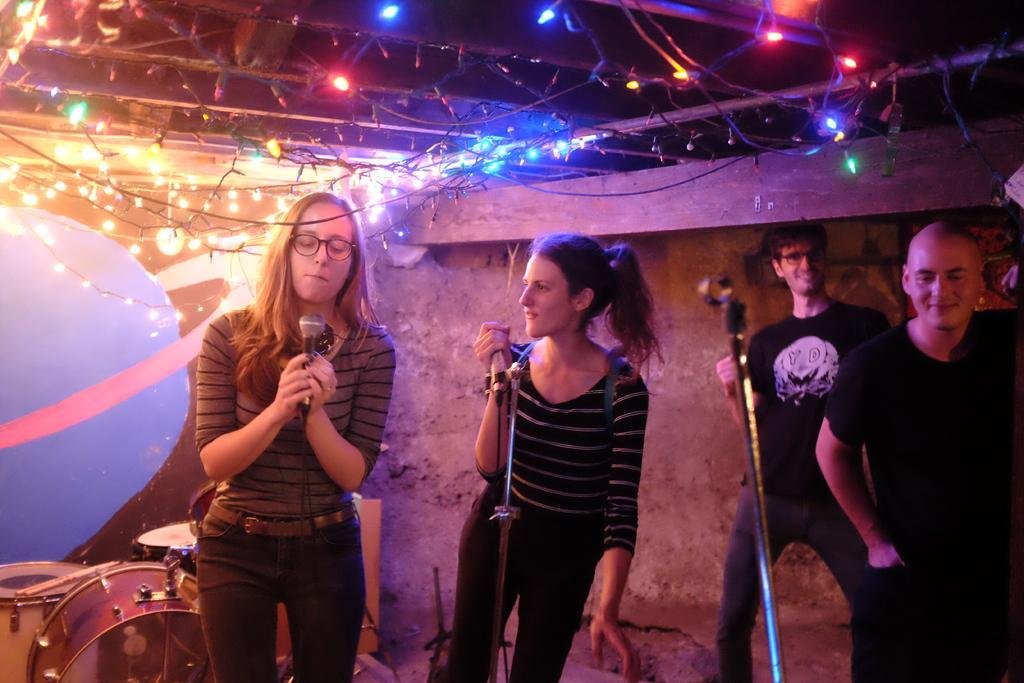Can you describe this image briefly? In this image we can see some group of persons standing and some are holding microphones in their hands and at the background of the image we can see drums and some musical instruments, lights and wall. 